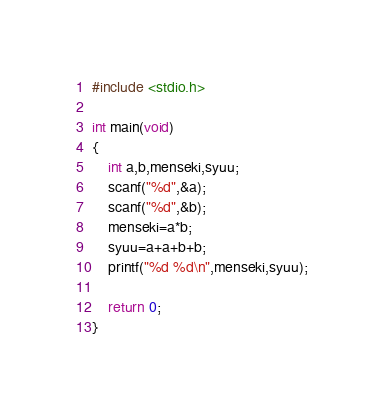Convert code to text. <code><loc_0><loc_0><loc_500><loc_500><_C_>#include <stdio.h>

int main(void)
{
	int a,b,menseki,syuu;
	scanf("%d",&a);
	scanf("%d",&b);
	menseki=a*b;
	syuu=a+a+b+b;
	printf("%d %d\n",menseki,syuu);
	
	return 0;
}
</code> 